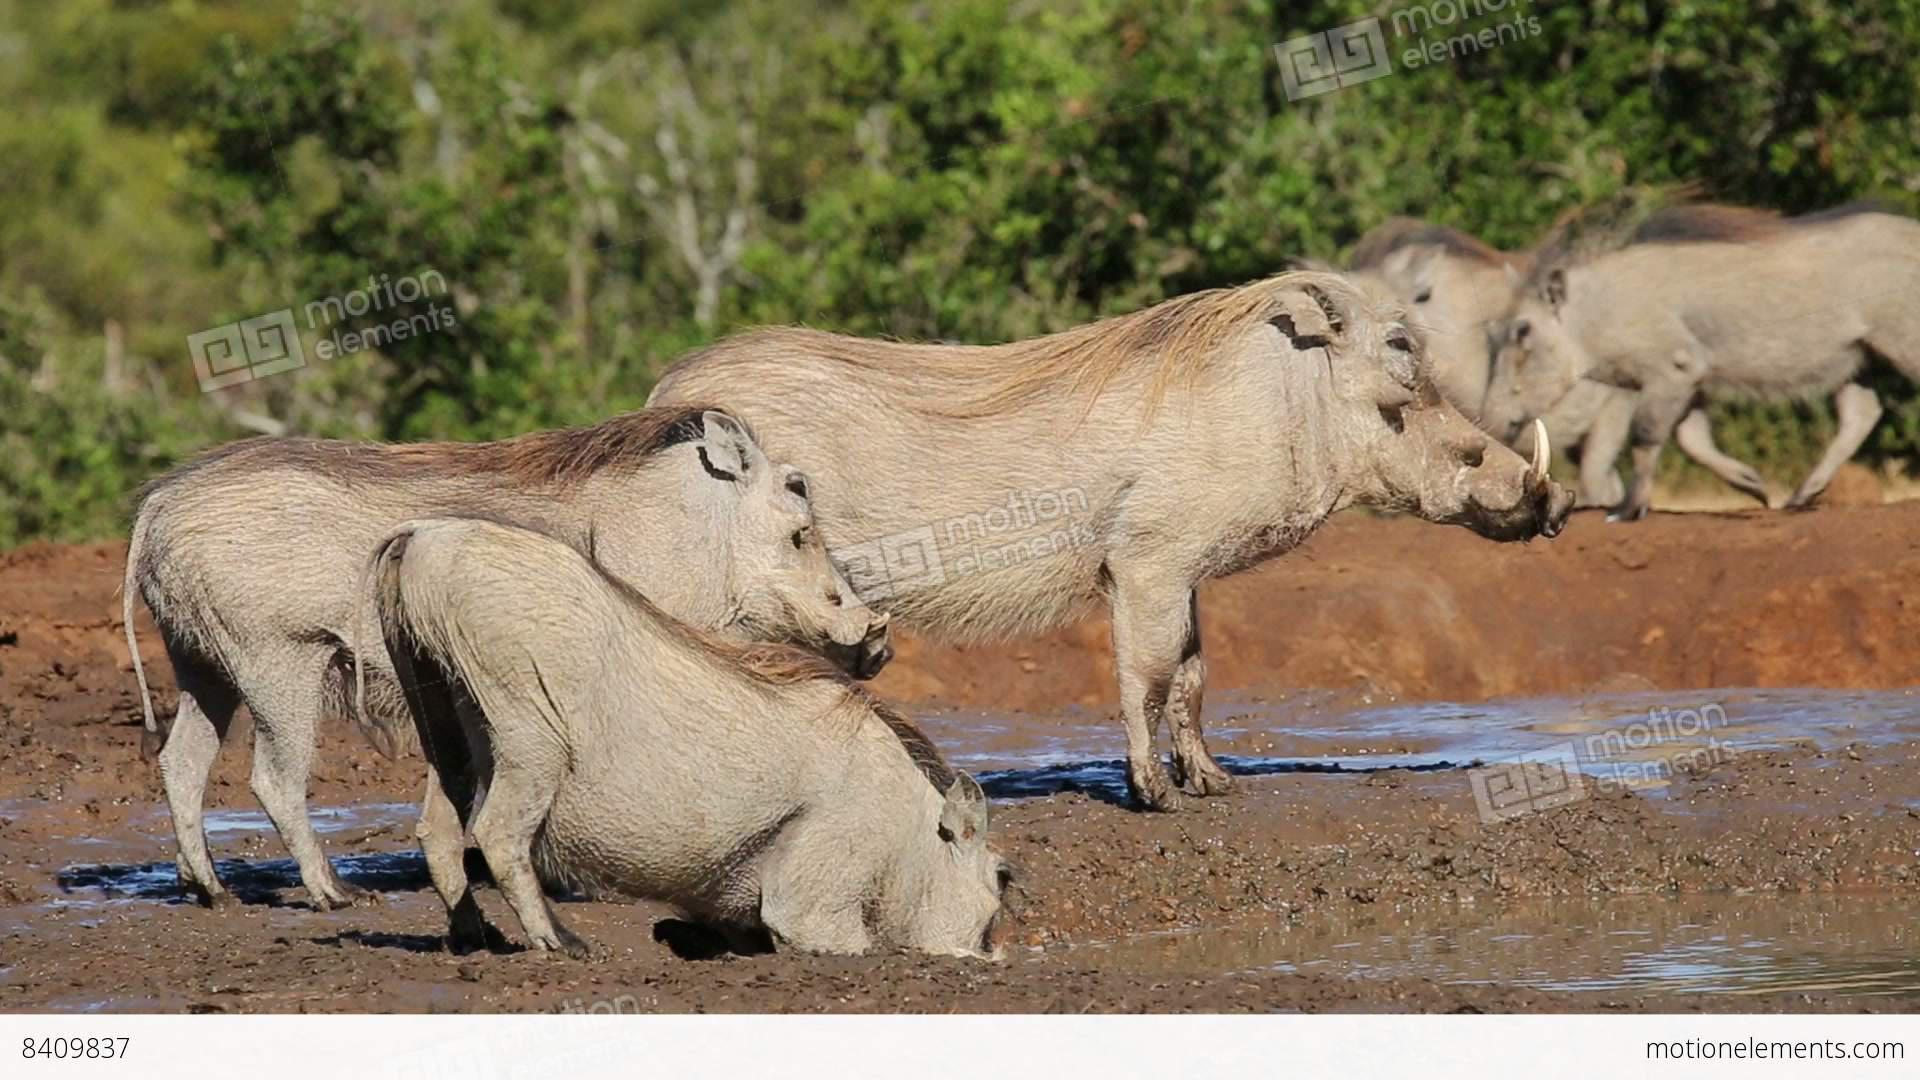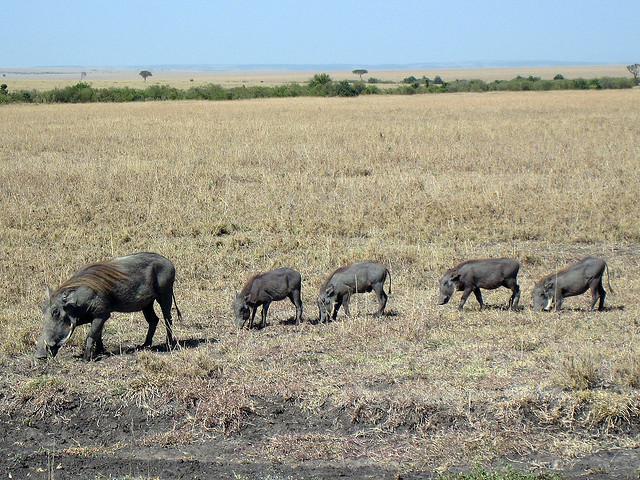The first image is the image on the left, the second image is the image on the right. Given the left and right images, does the statement "There is only one wart hog in the image on the left." hold true? Answer yes or no. No. The first image is the image on the left, the second image is the image on the right. Considering the images on both sides, is "There are 9 or more warthogs, and there are only brown ones in one of the pictures, and only black ones in the other picture." valid? Answer yes or no. Yes. 